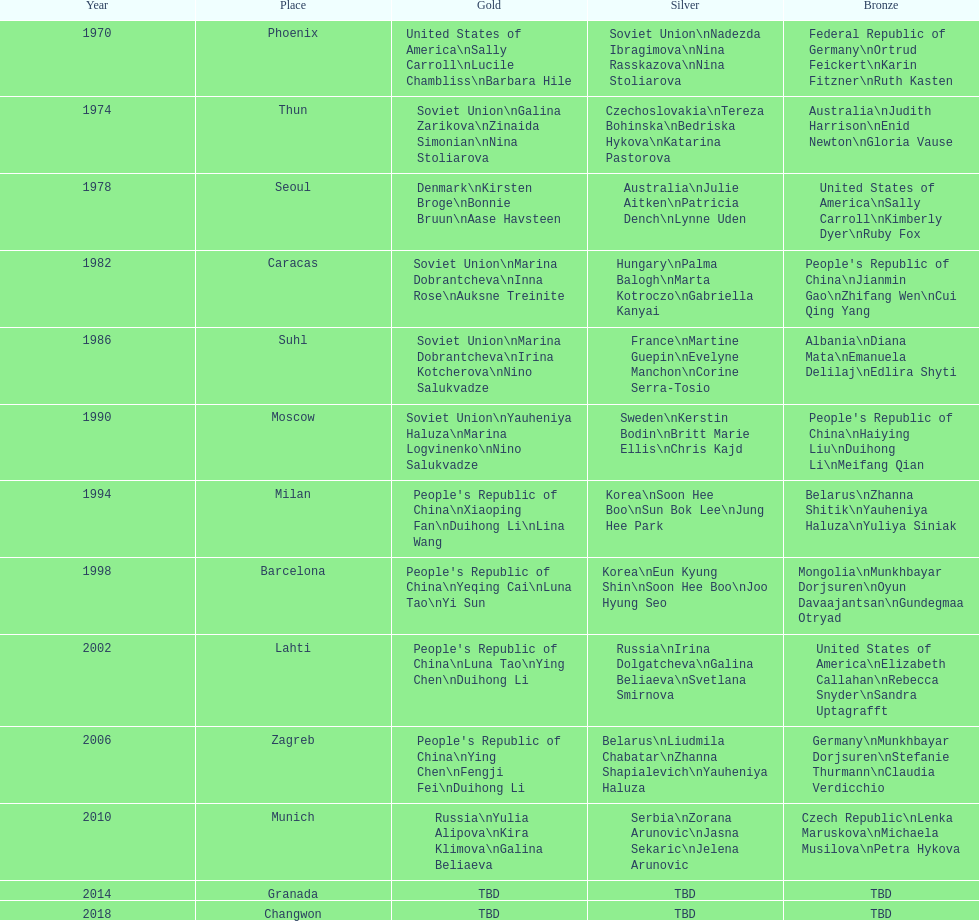How many occasions has germany achieved bronze? 2. 